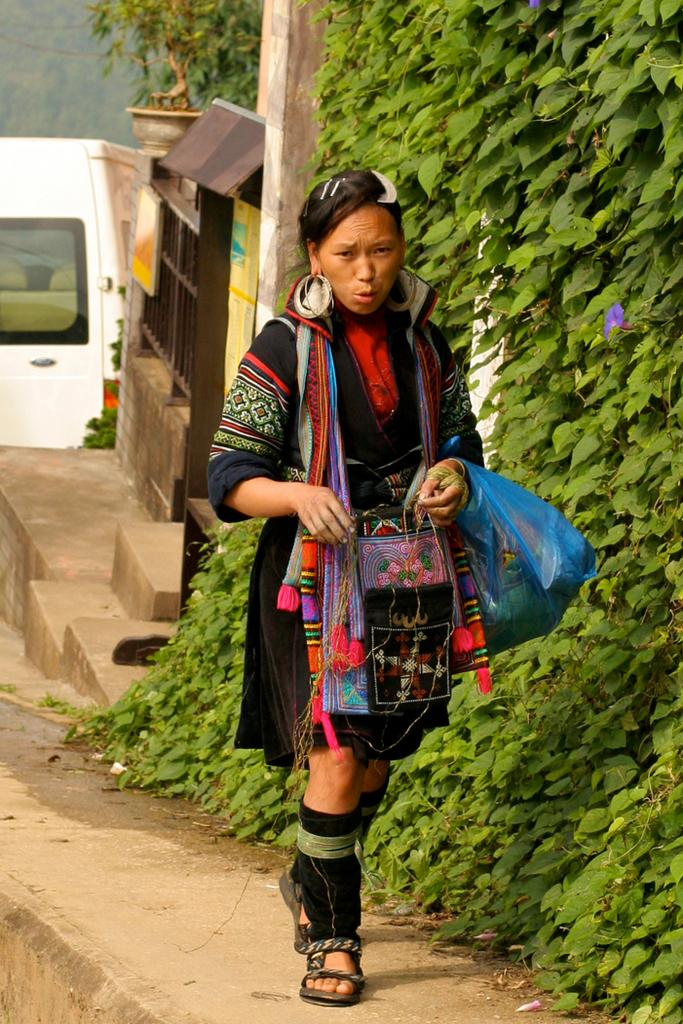Who is the main subject in the image? There is a woman in the image. What is the woman wearing? The woman is wearing a black dress. What is the woman doing in the image? The woman is walking. What type of vegetation is visible beside the woman? There are green trees beside the woman. What vehicle is visible behind the woman? There is a white van behind the woman. What sense is the woman using to read the calendar in the image? There is no calendar present in the image, so the woman is not reading one. 